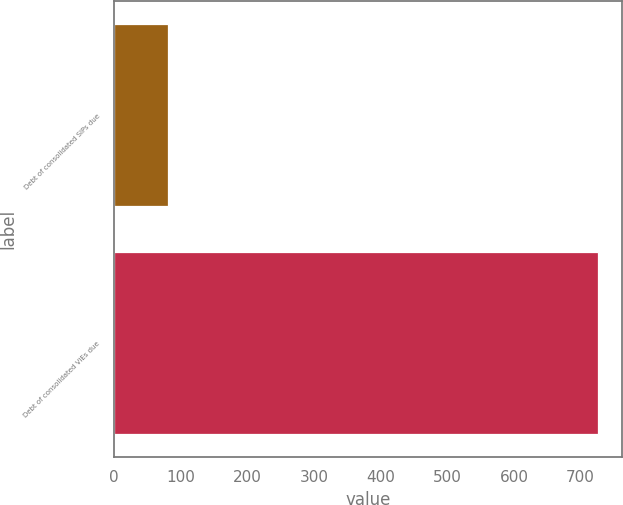<chart> <loc_0><loc_0><loc_500><loc_500><bar_chart><fcel>Debt of consolidated SIPs due<fcel>Debt of consolidated VIEs due<nl><fcel>81.2<fcel>726.1<nl></chart> 